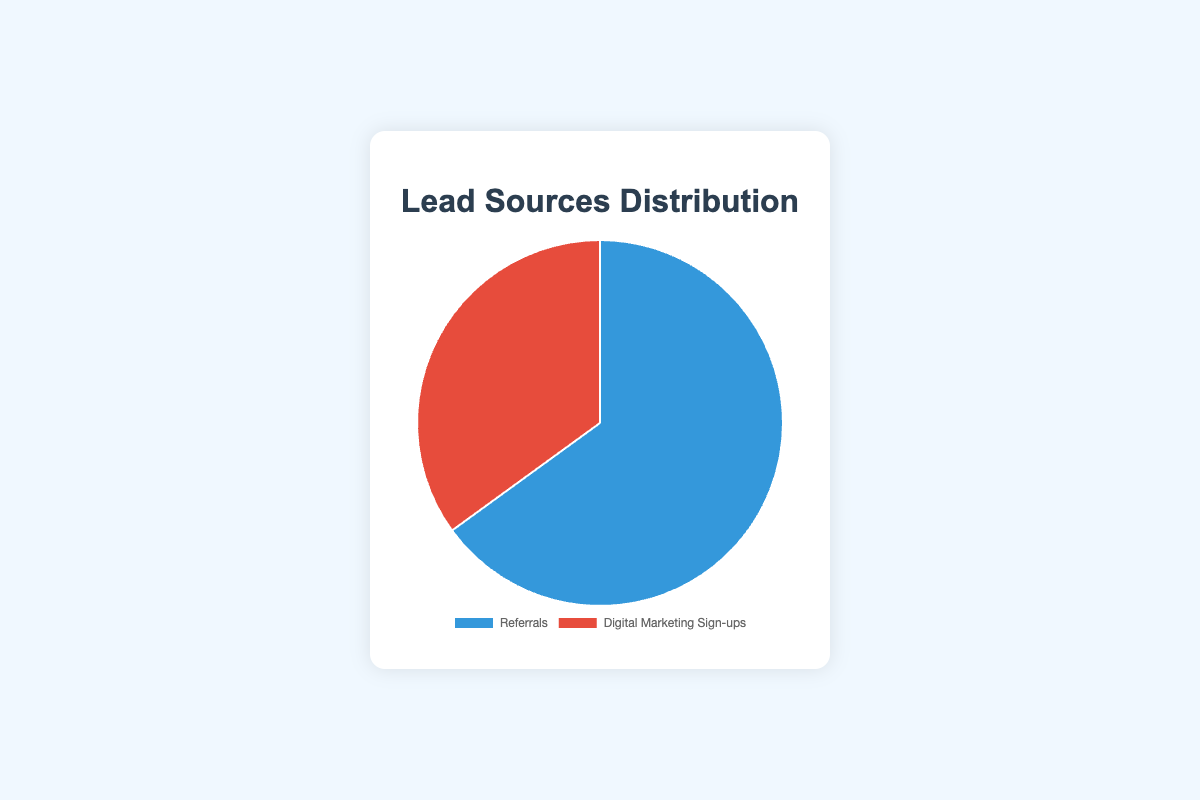What's the percentage of leads coming from referrals? The chart shows a section labeled "Referrals" with the percentage displayed on it.
Answer: 65% How does the percentage of digital marketing sign-ups compare to referrals? By looking at both sections of the pie chart, you see that referrals have a higher percentage than digital marketing sign-ups. Specifically, referrals are 65% while digital marketing sign-ups are 35%.
Answer: Referrals are higher What is the difference in percentage between referrals and digital marketing sign-ups? Subtract the percentage of digital marketing sign-ups (35%) from referrals (65%). 65% - 35% = 30%
Answer: 30% What is the total percentage represented in the chart? A pie chart represents the whole as 100%, so the total percentage represented is the sum of all sections: 65% + 35% = 100%.
Answer: 100% What visual element represents the referrals in the pie chart? Referrals are represented by the blue section of the pie chart.
Answer: Blue section If the percentage of digital marketing sign-ups increased to equal the referrals, what would each percentage be? If digital marketing sign-ups increased to match referrals, both would be 50% to make up the entire pie chart, which totals 100%.
Answer: 50% each Which lead source occupies a larger area on the pie chart? Referrals occupy a larger area on the pie chart compared to digital marketing sign-ups.
Answer: Referrals What is the ratio of referrals to digital marketing sign-ups? The ratio is determined by dividing the percentage of referrals by the percentage of digital marketing sign-ups: 65% / 35% = 1.857, which can be rounded to approximately 1.86.
Answer: 1.86 If you gain 10% more leads from digital marketing sign-ups, what would the new percentages be? If digital marketing sign-ups increase by 10%, they would be 35% + 10% = 45%. Since the total must be 100%, referrals would be 100% - 45% = 55%.
Answer: 55% referrals, 45% digital marketing sign-ups What fraction of the leads are coming from digital marketing sign-ups? Convert the percentage of digital marketing sign-ups into a fraction: 35% = 35/100 = 7/20.
Answer: 7/20 